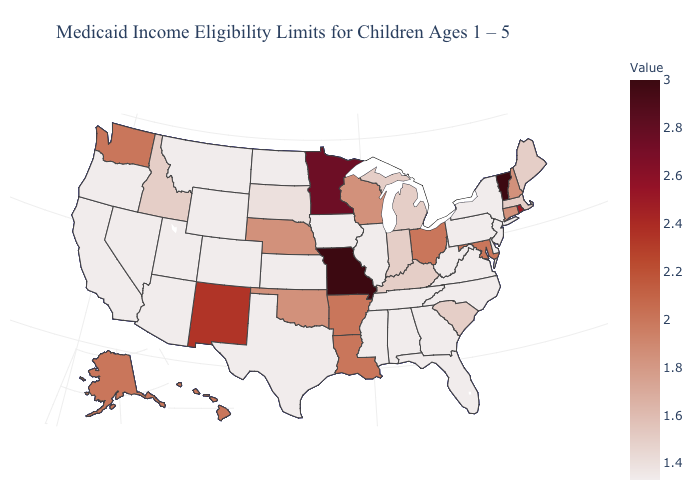Does New Mexico have the highest value in the USA?
Quick response, please. No. Does the map have missing data?
Give a very brief answer. No. Does Hawaii have the lowest value in the USA?
Concise answer only. No. Which states hav the highest value in the Northeast?
Concise answer only. Vermont. Which states have the lowest value in the USA?
Quick response, please. Alabama, Arizona, California, Colorado, Delaware, Florida, Georgia, Illinois, Iowa, Kansas, Mississippi, Montana, Nevada, New Jersey, New York, North Carolina, North Dakota, Oregon, Pennsylvania, Tennessee, Texas, Utah, Virginia, West Virginia, Wyoming. 